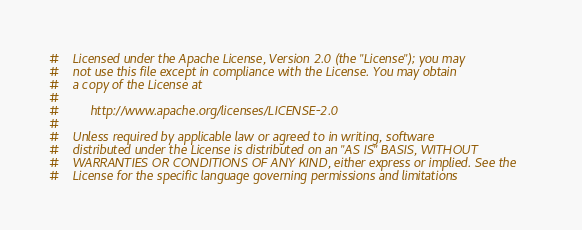Convert code to text. <code><loc_0><loc_0><loc_500><loc_500><_Python_>#    Licensed under the Apache License, Version 2.0 (the "License"); you may
#    not use this file except in compliance with the License. You may obtain
#    a copy of the License at
#
#         http://www.apache.org/licenses/LICENSE-2.0
#
#    Unless required by applicable law or agreed to in writing, software
#    distributed under the License is distributed on an "AS IS" BASIS, WITHOUT
#    WARRANTIES OR CONDITIONS OF ANY KIND, either express or implied. See the
#    License for the specific language governing permissions and limitations</code> 